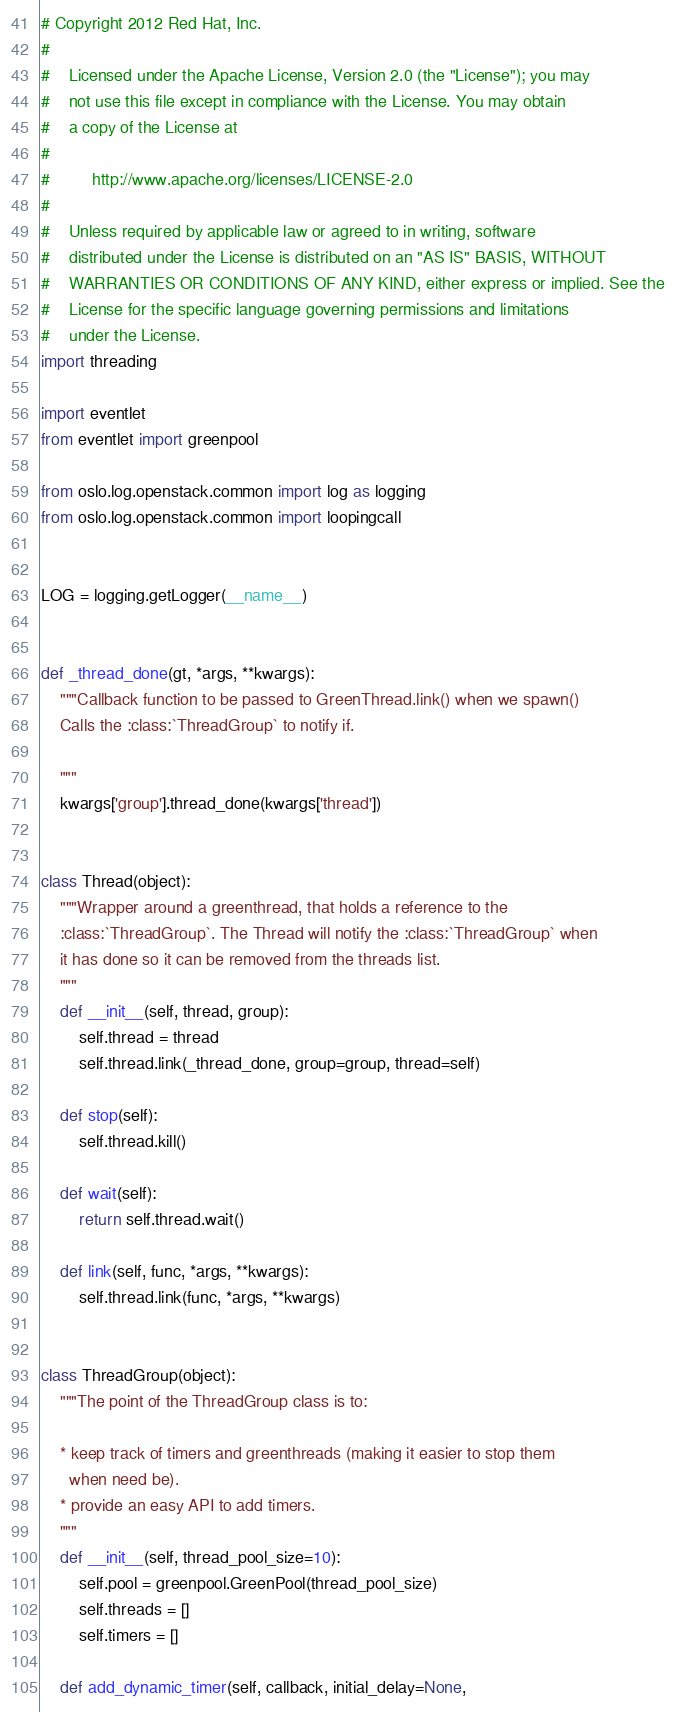Convert code to text. <code><loc_0><loc_0><loc_500><loc_500><_Python_># Copyright 2012 Red Hat, Inc.
#
#    Licensed under the Apache License, Version 2.0 (the "License"); you may
#    not use this file except in compliance with the License. You may obtain
#    a copy of the License at
#
#         http://www.apache.org/licenses/LICENSE-2.0
#
#    Unless required by applicable law or agreed to in writing, software
#    distributed under the License is distributed on an "AS IS" BASIS, WITHOUT
#    WARRANTIES OR CONDITIONS OF ANY KIND, either express or implied. See the
#    License for the specific language governing permissions and limitations
#    under the License.
import threading

import eventlet
from eventlet import greenpool

from oslo.log.openstack.common import log as logging
from oslo.log.openstack.common import loopingcall


LOG = logging.getLogger(__name__)


def _thread_done(gt, *args, **kwargs):
    """Callback function to be passed to GreenThread.link() when we spawn()
    Calls the :class:`ThreadGroup` to notify if.

    """
    kwargs['group'].thread_done(kwargs['thread'])


class Thread(object):
    """Wrapper around a greenthread, that holds a reference to the
    :class:`ThreadGroup`. The Thread will notify the :class:`ThreadGroup` when
    it has done so it can be removed from the threads list.
    """
    def __init__(self, thread, group):
        self.thread = thread
        self.thread.link(_thread_done, group=group, thread=self)

    def stop(self):
        self.thread.kill()

    def wait(self):
        return self.thread.wait()

    def link(self, func, *args, **kwargs):
        self.thread.link(func, *args, **kwargs)


class ThreadGroup(object):
    """The point of the ThreadGroup class is to:

    * keep track of timers and greenthreads (making it easier to stop them
      when need be).
    * provide an easy API to add timers.
    """
    def __init__(self, thread_pool_size=10):
        self.pool = greenpool.GreenPool(thread_pool_size)
        self.threads = []
        self.timers = []

    def add_dynamic_timer(self, callback, initial_delay=None,</code> 